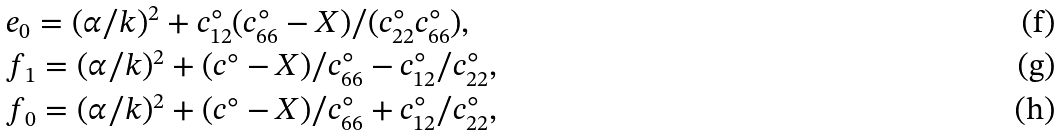<formula> <loc_0><loc_0><loc_500><loc_500>& e _ { 0 } = ( \alpha / k ) ^ { 2 } + c ^ { \circ } _ { 1 2 } ( c ^ { \circ } _ { 6 6 } - X ) / ( c ^ { \circ } _ { 2 2 } c ^ { \circ } _ { 6 6 } ) , \\ & f _ { 1 } = ( \alpha / k ) ^ { 2 } + ( c ^ { \circ } - X ) / c ^ { \circ } _ { 6 6 } - c ^ { \circ } _ { 1 2 } / c ^ { \circ } _ { 2 2 } , \\ & f _ { 0 } = ( \alpha / k ) ^ { 2 } + ( c ^ { \circ } - X ) / c ^ { \circ } _ { 6 6 } + c ^ { \circ } _ { 1 2 } / c ^ { \circ } _ { 2 2 } ,</formula> 